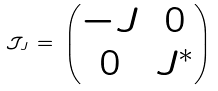Convert formula to latex. <formula><loc_0><loc_0><loc_500><loc_500>\mathcal { J } _ { J } \, = \, \begin{pmatrix} - J & 0 \\ 0 & J ^ { * } \end{pmatrix}</formula> 